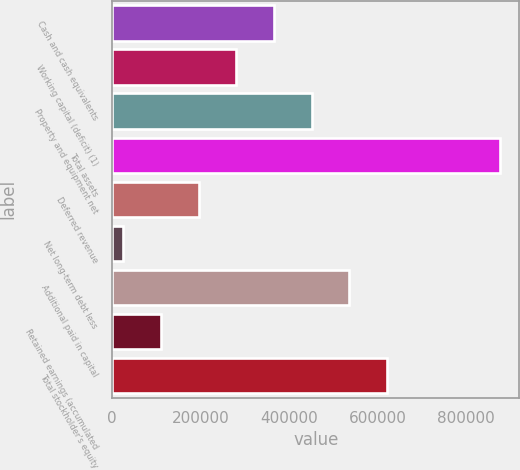Convert chart to OTSL. <chart><loc_0><loc_0><loc_500><loc_500><bar_chart><fcel>Cash and cash equivalents<fcel>Working capital (deficit) (1)<fcel>Property and equipment net<fcel>Total assets<fcel>Deferred revenue<fcel>Net long-term debt less<fcel>Additional paid in capital<fcel>Retained earnings (accumulated<fcel>Total stockholder's equity<nl><fcel>365576<fcel>280396<fcel>450756<fcel>876655<fcel>195216<fcel>24856<fcel>535935<fcel>110036<fcel>621115<nl></chart> 